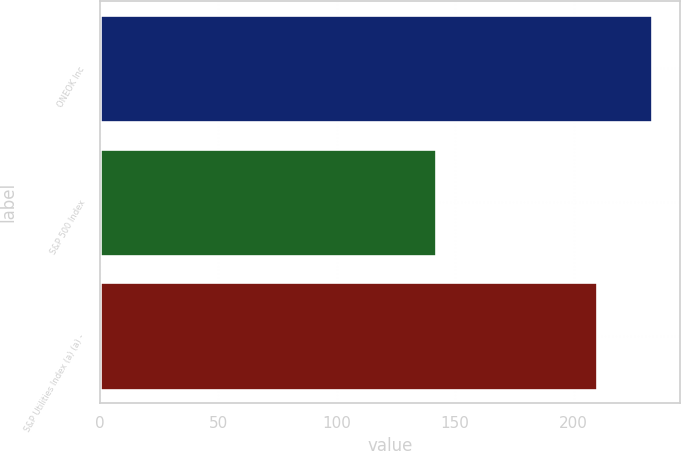Convert chart. <chart><loc_0><loc_0><loc_500><loc_500><bar_chart><fcel>ONEOK Inc<fcel>S&P 500 Index<fcel>S&P Utilities Index (a) (a) -<nl><fcel>233.19<fcel>142.09<fcel>209.73<nl></chart> 